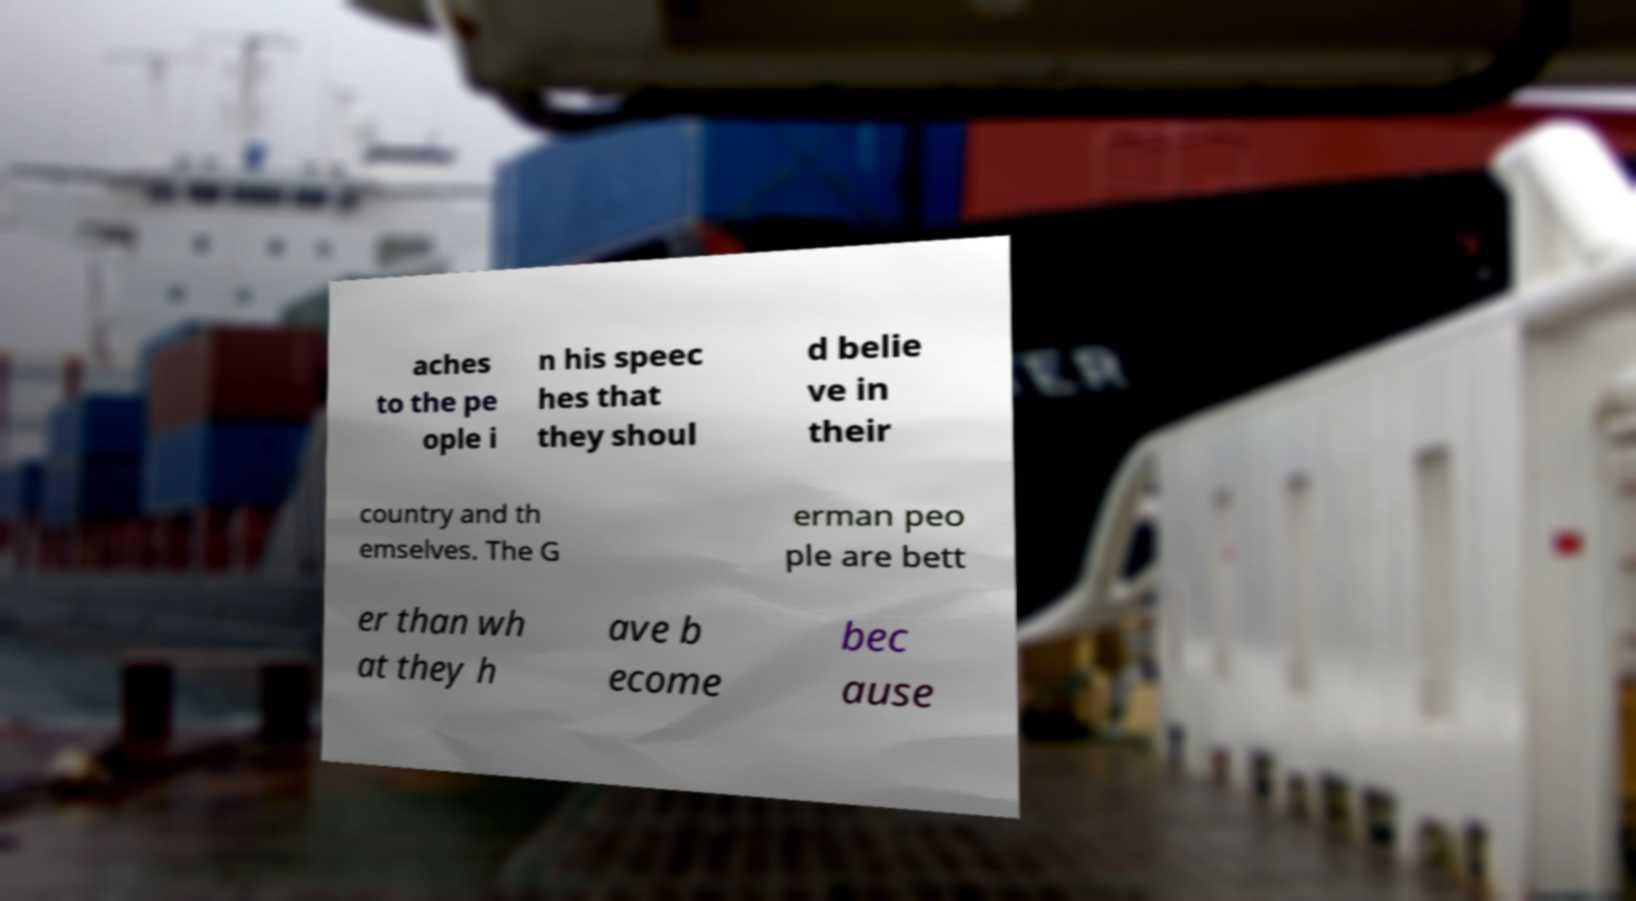What messages or text are displayed in this image? I need them in a readable, typed format. aches to the pe ople i n his speec hes that they shoul d belie ve in their country and th emselves. The G erman peo ple are bett er than wh at they h ave b ecome bec ause 